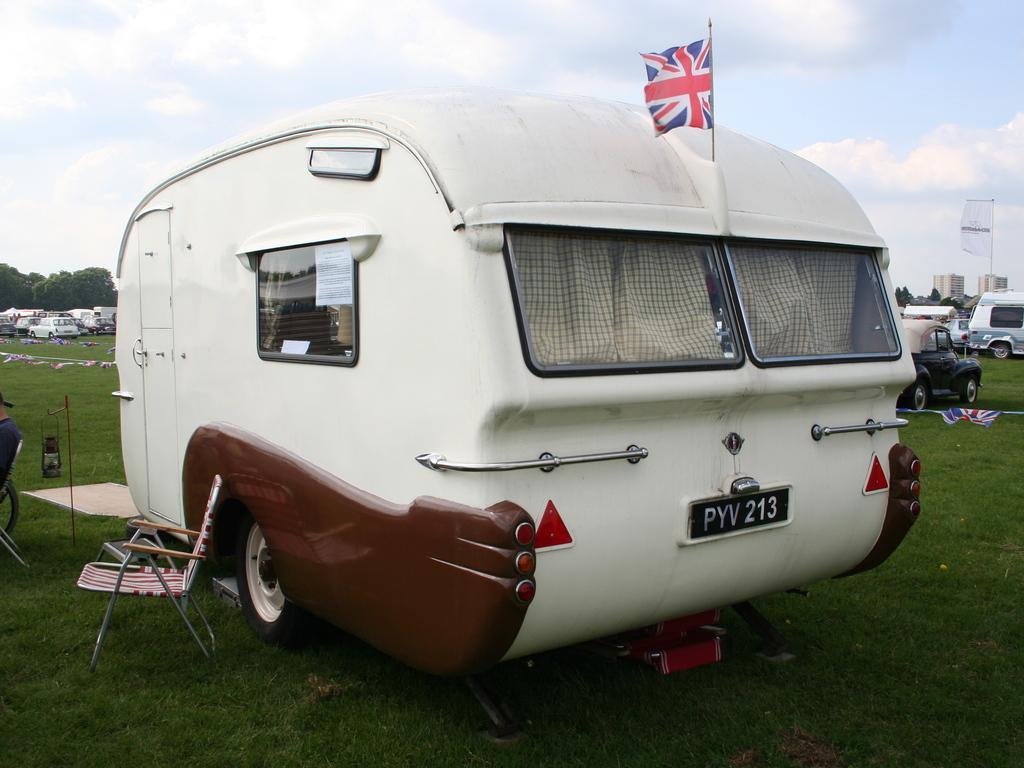Please provide a concise description of this image. In this image there are vehicles, banner, flags, chair, lantern lamp, grass, trees, buildings, cloudy sky and objects. Land is covered with grass. In the background of the image there are buildings, trees and cloudy sky. 